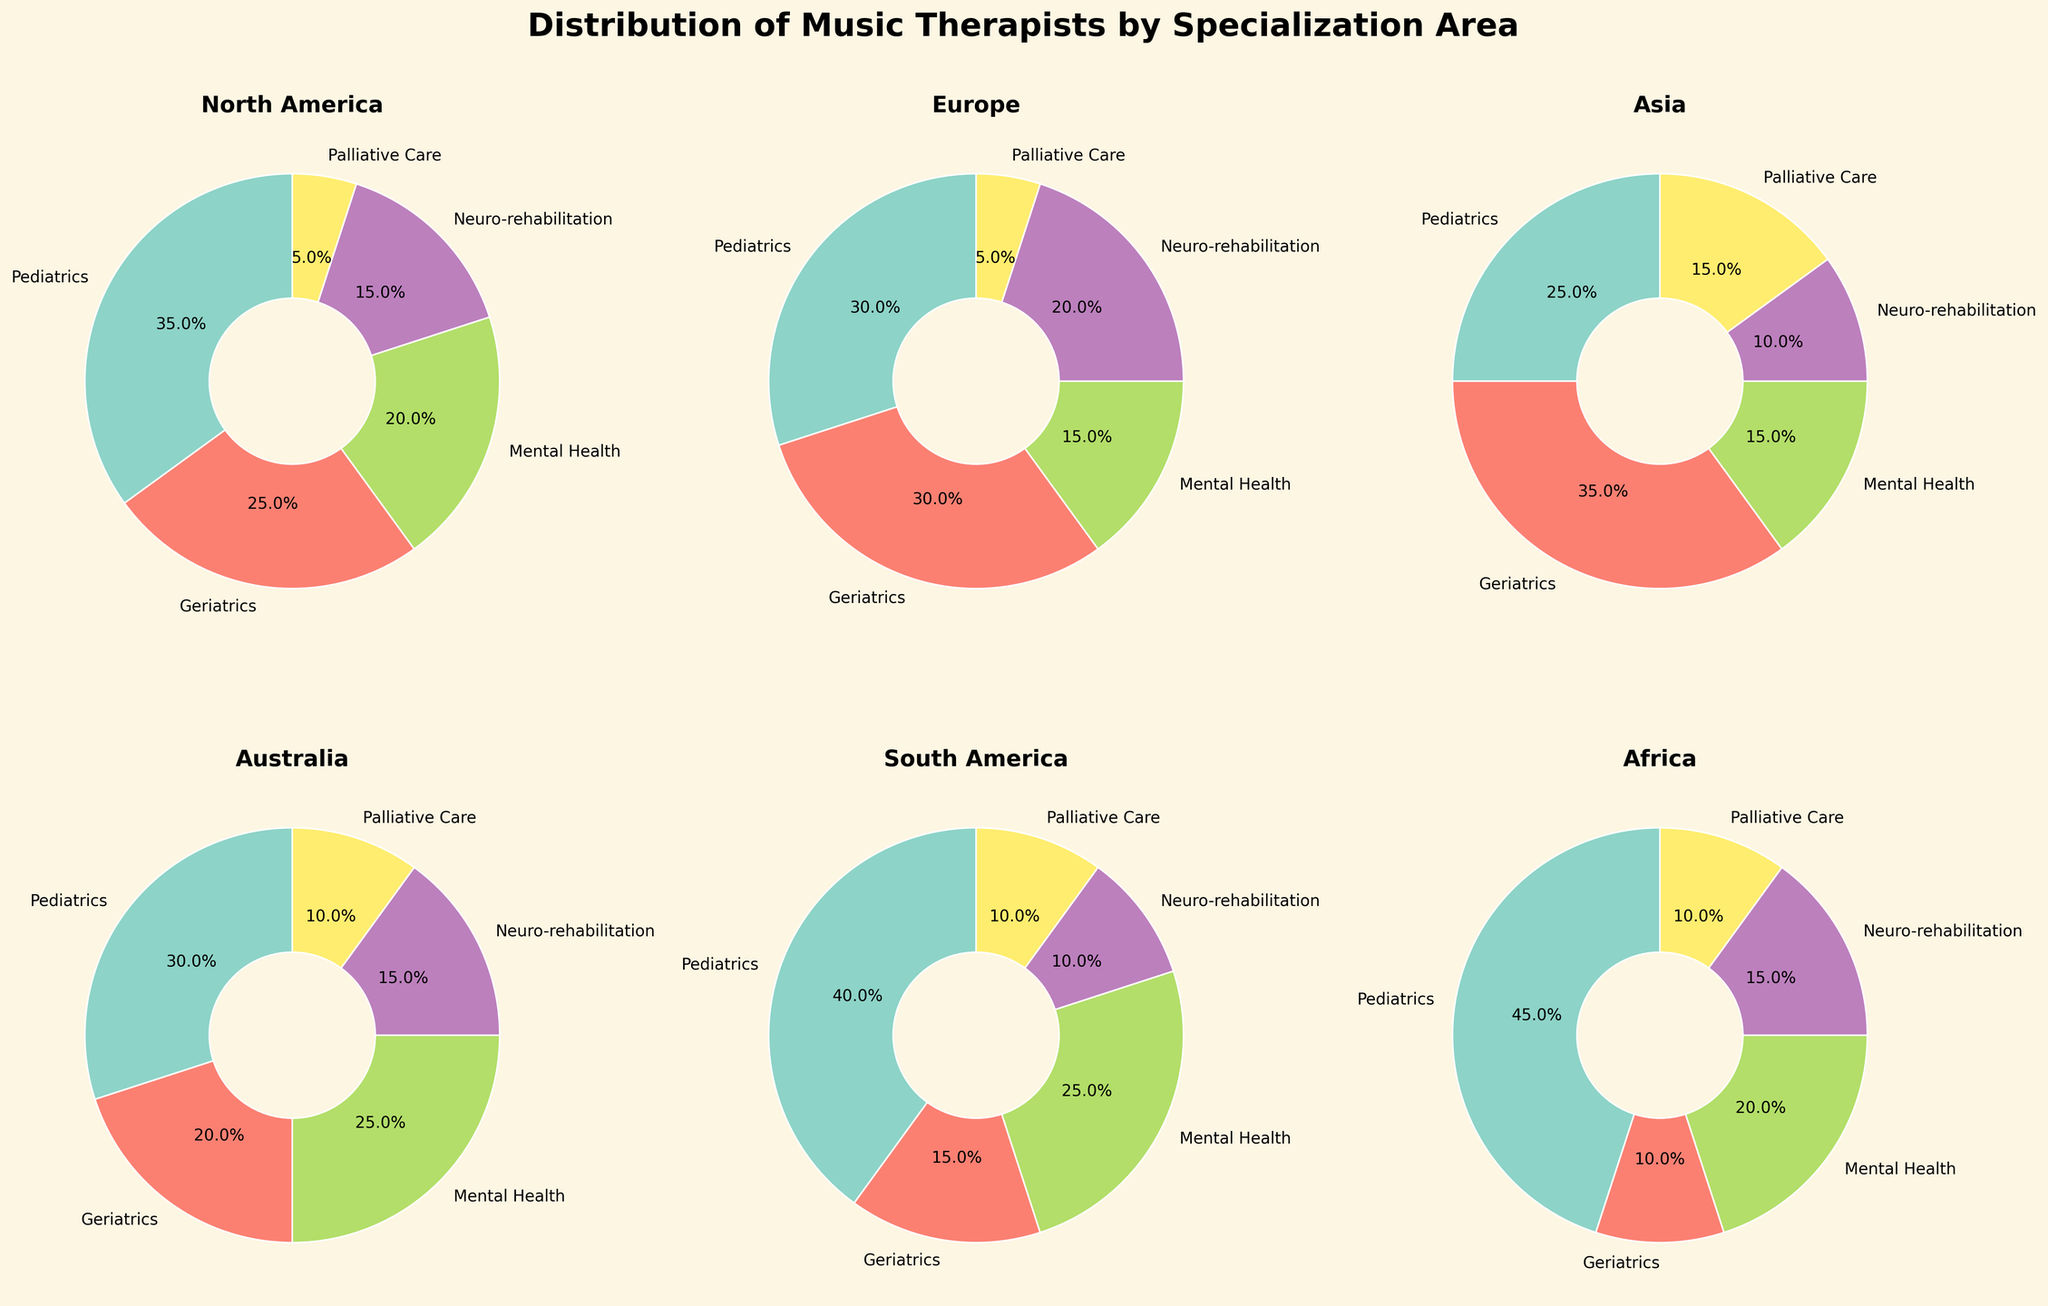What's the title of the figure? The title is at the top center of the figure, stating the main theme of the plots. The suptitle reads 'Distribution of Music Therapists by Specialization Area'.
Answer: Distribution of Music Therapists by Specialization Area How many regions are displayed in the figure? The figure has a 2 by 3 layout, but only the first six subplots have data. This corresponds to the six regions mentioned.
Answer: Six Which region has the highest percentage of music therapists specializing in Palliative Care? By looking at the Palliative Care segment in each pie chart, labeled in percentages, Asia has the highest value at 15%.
Answer: Asia What is the percentage of music therapists specializing in Pediatrics in North America? In the North America pie chart, find the Pediatrics segment and note the displayed percentage. It is 35%.
Answer: 35% Compare the percentage of therapists specializing in Geriatrics between Europe and Australia. Which region has a higher percentage? Look at both regions' pie charts and compare the Geriatrics sector percentages. Europe has 30%, while Australia has 20%.
Answer: Europe What is the most common specialization for music therapists in Africa? Identify the largest segment in the Africa pie chart. Pediatrics has the largest percentage of 45%.
Answer: Pediatrics How does the percentage of therapists specializing in Mental Health in South America compare to that in North America? Note the Mental Health segment percentages in both South America and North America's pie charts. Both regions have 25%.
Answer: Equal Which specialization area has the smallest representation in North America? Look at the North America pie chart and identify the smallest segment. Palliative Care is the smallest at 5%.
Answer: Palliative Care Calculate the average percentage of music therapists specializing in Neuro-rehabilitation across all regions. Add the Neuro-rehabilitation percentages for all regions (15+20+10+15+10+15 = 85) and divide by 6 regions: 85/6 ≈ 14.2%.
Answer: 14.2% What percentage of music therapists in South America specialize in Pediatrics and Mental Health combined? Add the percentages for Pediatrics (40%) and Mental Health (25%) from the South America pie chart: 40% + 25% = 65%.
Answer: 65% 